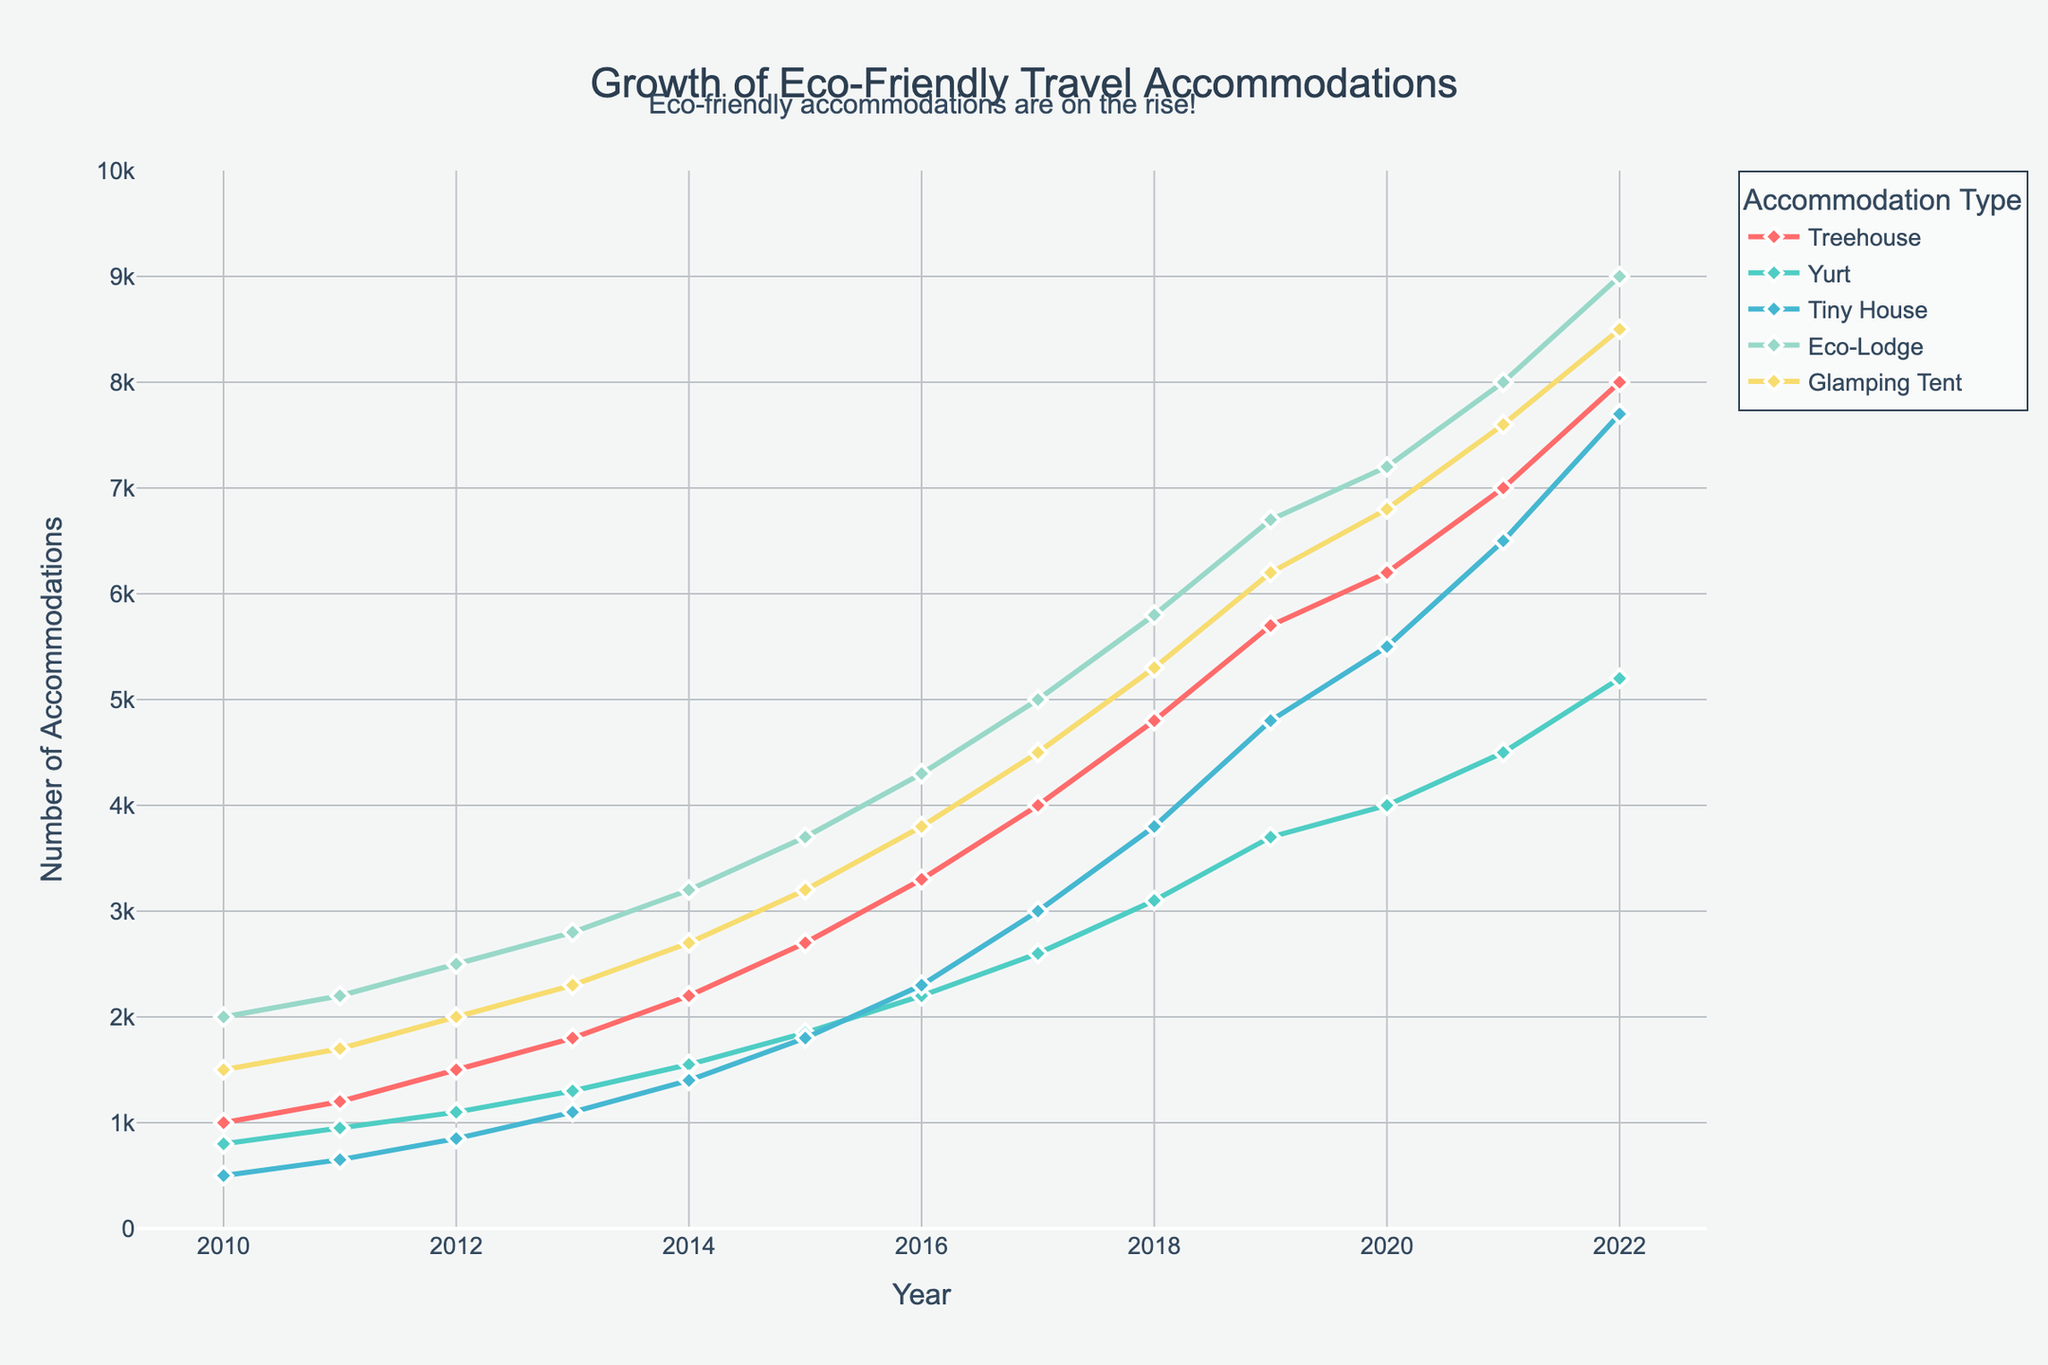Which eco-friendly accommodation type experienced the highest growth between 2010 and 2022? To find the accommodation type with the highest growth, look at the vertical distance between the 2010 and 2022 points on the y-axis for each type. Treehouse starts at 1000 and reaches 8000, growing by 7000. Yurt grows from 800 to 5200, which is 4400. Tiny House increases from 500 to 7700, a growth of 7200. Eco-Lodge goes from 2000 to 9000, growing by 7000. Glamping Tent goes from 1500 to 8500, a growth of 7000. Comparing these, Tiny House experienced the highest growth of 7200.
Answer: Tiny House In which year did Eco-Lodge overtake Treehouse in terms of number of accommodations? To determine when Eco-Lodge overtook Treehouse, observe their respective lines on the plot. Treehouse and Eco-Lodge intersect around the year 2017, after which Eco-Lodge has more accommodations than Treehouse.
Answer: 2017 What was the difference in the number of Tiny House and Glamping Tent accommodations in 2022? Look at the y-axis values for Tiny House and Glamping Tent in the year 2022. Tiny House has 7700 accommodations, and Glamping Tent has 8500. Subtract the Tiny House value from the Glamping Tent value: 8500 - 7700 = 800.
Answer: 800 What was the average number of accommodations for Eco-Lodge from 2010 to 2022? To find the average, sum the number of Eco-Lodge accommodations from 2010 to 2022 and divide by the number of years. Sum: 2000 + 2200 + 2500 + 2800 + 3200 + 3700 + 4300 + 5000 + 5800 + 6700 + 7200 + 8000 + 9000 = 79400. There are 13 years, so divide 79400 by 13: 79400 / 13 ≈ 6107.69.
Answer: 6108 Which accommodation types had an equal number of accommodations in any given year? By examining the figure, identify if any lines overlap at any year. Treehouse, Eco-Lodge, and Glamping Tent each had 7000 accommodations in 2021, so they are equal in that year.
Answer: Treehouse, Eco-Lodge, Glamping Tent How much did Yurt accommodations increase on average each year from 2010 to 2022? To determine the average annual increase, find the difference between the 2022 and 2010 values for Yurt and divide by the number of years. Increase: 5200 - 800 = 4400. Divide by the number of years (2022 - 2010 = 12): 4400 / 12 ≈ 366.67.
Answer: 367 